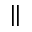<formula> <loc_0><loc_0><loc_500><loc_500>\|</formula> 